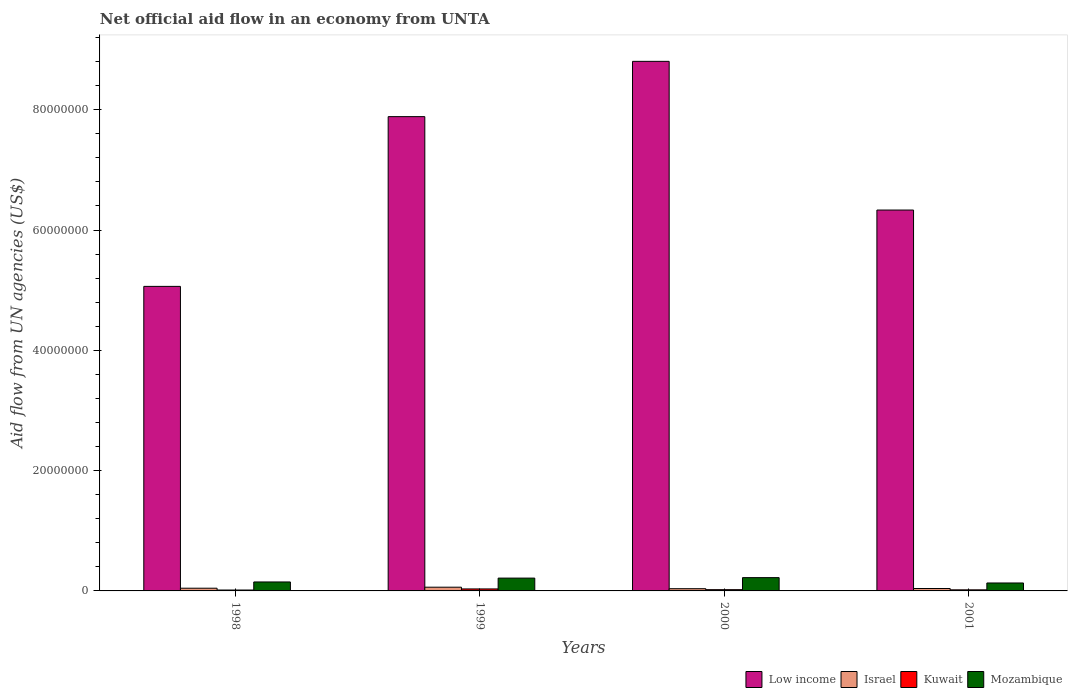How many different coloured bars are there?
Your response must be concise. 4. Are the number of bars per tick equal to the number of legend labels?
Keep it short and to the point. Yes. What is the label of the 4th group of bars from the left?
Keep it short and to the point. 2001. Across all years, what is the maximum net official aid flow in Mozambique?
Give a very brief answer. 2.21e+06. In which year was the net official aid flow in Israel minimum?
Ensure brevity in your answer.  2000. What is the total net official aid flow in Low income in the graph?
Provide a succinct answer. 2.81e+08. What is the difference between the net official aid flow in Israel in 2000 and that in 2001?
Your response must be concise. -3.00e+04. What is the difference between the net official aid flow in Kuwait in 2001 and the net official aid flow in Low income in 1999?
Give a very brief answer. -7.87e+07. What is the average net official aid flow in Mozambique per year?
Your response must be concise. 1.79e+06. In the year 1998, what is the difference between the net official aid flow in Mozambique and net official aid flow in Kuwait?
Offer a very short reply. 1.34e+06. What is the ratio of the net official aid flow in Mozambique in 1999 to that in 2000?
Keep it short and to the point. 0.96. Is the difference between the net official aid flow in Mozambique in 1999 and 2000 greater than the difference between the net official aid flow in Kuwait in 1999 and 2000?
Your answer should be compact. No. What is the difference between the highest and the lowest net official aid flow in Israel?
Your answer should be very brief. 2.50e+05. What does the 1st bar from the left in 2001 represents?
Give a very brief answer. Low income. What does the 1st bar from the right in 2001 represents?
Give a very brief answer. Mozambique. Are all the bars in the graph horizontal?
Offer a very short reply. No. What is the difference between two consecutive major ticks on the Y-axis?
Keep it short and to the point. 2.00e+07. Where does the legend appear in the graph?
Make the answer very short. Bottom right. How are the legend labels stacked?
Your answer should be compact. Horizontal. What is the title of the graph?
Your answer should be compact. Net official aid flow in an economy from UNTA. Does "Maldives" appear as one of the legend labels in the graph?
Keep it short and to the point. No. What is the label or title of the X-axis?
Give a very brief answer. Years. What is the label or title of the Y-axis?
Ensure brevity in your answer.  Aid flow from UN agencies (US$). What is the Aid flow from UN agencies (US$) of Low income in 1998?
Provide a short and direct response. 5.06e+07. What is the Aid flow from UN agencies (US$) in Kuwait in 1998?
Your response must be concise. 1.50e+05. What is the Aid flow from UN agencies (US$) of Mozambique in 1998?
Offer a very short reply. 1.49e+06. What is the Aid flow from UN agencies (US$) of Low income in 1999?
Keep it short and to the point. 7.88e+07. What is the Aid flow from UN agencies (US$) of Israel in 1999?
Make the answer very short. 6.20e+05. What is the Aid flow from UN agencies (US$) of Mozambique in 1999?
Keep it short and to the point. 2.13e+06. What is the Aid flow from UN agencies (US$) of Low income in 2000?
Ensure brevity in your answer.  8.80e+07. What is the Aid flow from UN agencies (US$) of Israel in 2000?
Provide a succinct answer. 3.70e+05. What is the Aid flow from UN agencies (US$) in Kuwait in 2000?
Give a very brief answer. 2.10e+05. What is the Aid flow from UN agencies (US$) in Mozambique in 2000?
Offer a terse response. 2.21e+06. What is the Aid flow from UN agencies (US$) of Low income in 2001?
Your answer should be compact. 6.33e+07. What is the Aid flow from UN agencies (US$) of Israel in 2001?
Provide a short and direct response. 4.00e+05. What is the Aid flow from UN agencies (US$) of Mozambique in 2001?
Offer a terse response. 1.32e+06. Across all years, what is the maximum Aid flow from UN agencies (US$) of Low income?
Give a very brief answer. 8.80e+07. Across all years, what is the maximum Aid flow from UN agencies (US$) in Israel?
Your response must be concise. 6.20e+05. Across all years, what is the maximum Aid flow from UN agencies (US$) of Mozambique?
Your response must be concise. 2.21e+06. Across all years, what is the minimum Aid flow from UN agencies (US$) of Low income?
Your response must be concise. 5.06e+07. Across all years, what is the minimum Aid flow from UN agencies (US$) in Israel?
Ensure brevity in your answer.  3.70e+05. Across all years, what is the minimum Aid flow from UN agencies (US$) of Kuwait?
Your answer should be compact. 1.50e+05. Across all years, what is the minimum Aid flow from UN agencies (US$) of Mozambique?
Your response must be concise. 1.32e+06. What is the total Aid flow from UN agencies (US$) of Low income in the graph?
Offer a terse response. 2.81e+08. What is the total Aid flow from UN agencies (US$) of Israel in the graph?
Offer a terse response. 1.84e+06. What is the total Aid flow from UN agencies (US$) in Kuwait in the graph?
Give a very brief answer. 8.70e+05. What is the total Aid flow from UN agencies (US$) of Mozambique in the graph?
Give a very brief answer. 7.15e+06. What is the difference between the Aid flow from UN agencies (US$) of Low income in 1998 and that in 1999?
Make the answer very short. -2.82e+07. What is the difference between the Aid flow from UN agencies (US$) in Israel in 1998 and that in 1999?
Provide a short and direct response. -1.70e+05. What is the difference between the Aid flow from UN agencies (US$) of Kuwait in 1998 and that in 1999?
Offer a very short reply. -1.80e+05. What is the difference between the Aid flow from UN agencies (US$) of Mozambique in 1998 and that in 1999?
Offer a terse response. -6.40e+05. What is the difference between the Aid flow from UN agencies (US$) of Low income in 1998 and that in 2000?
Your answer should be very brief. -3.74e+07. What is the difference between the Aid flow from UN agencies (US$) in Israel in 1998 and that in 2000?
Ensure brevity in your answer.  8.00e+04. What is the difference between the Aid flow from UN agencies (US$) of Mozambique in 1998 and that in 2000?
Your answer should be very brief. -7.20e+05. What is the difference between the Aid flow from UN agencies (US$) of Low income in 1998 and that in 2001?
Your answer should be very brief. -1.27e+07. What is the difference between the Aid flow from UN agencies (US$) in Low income in 1999 and that in 2000?
Provide a succinct answer. -9.19e+06. What is the difference between the Aid flow from UN agencies (US$) in Mozambique in 1999 and that in 2000?
Your response must be concise. -8.00e+04. What is the difference between the Aid flow from UN agencies (US$) in Low income in 1999 and that in 2001?
Make the answer very short. 1.55e+07. What is the difference between the Aid flow from UN agencies (US$) in Kuwait in 1999 and that in 2001?
Provide a short and direct response. 1.50e+05. What is the difference between the Aid flow from UN agencies (US$) of Mozambique in 1999 and that in 2001?
Your answer should be compact. 8.10e+05. What is the difference between the Aid flow from UN agencies (US$) in Low income in 2000 and that in 2001?
Your response must be concise. 2.47e+07. What is the difference between the Aid flow from UN agencies (US$) in Israel in 2000 and that in 2001?
Provide a short and direct response. -3.00e+04. What is the difference between the Aid flow from UN agencies (US$) of Mozambique in 2000 and that in 2001?
Your answer should be compact. 8.90e+05. What is the difference between the Aid flow from UN agencies (US$) of Low income in 1998 and the Aid flow from UN agencies (US$) of Israel in 1999?
Your response must be concise. 5.00e+07. What is the difference between the Aid flow from UN agencies (US$) in Low income in 1998 and the Aid flow from UN agencies (US$) in Kuwait in 1999?
Ensure brevity in your answer.  5.03e+07. What is the difference between the Aid flow from UN agencies (US$) in Low income in 1998 and the Aid flow from UN agencies (US$) in Mozambique in 1999?
Your response must be concise. 4.85e+07. What is the difference between the Aid flow from UN agencies (US$) in Israel in 1998 and the Aid flow from UN agencies (US$) in Kuwait in 1999?
Provide a short and direct response. 1.20e+05. What is the difference between the Aid flow from UN agencies (US$) of Israel in 1998 and the Aid flow from UN agencies (US$) of Mozambique in 1999?
Your answer should be compact. -1.68e+06. What is the difference between the Aid flow from UN agencies (US$) of Kuwait in 1998 and the Aid flow from UN agencies (US$) of Mozambique in 1999?
Give a very brief answer. -1.98e+06. What is the difference between the Aid flow from UN agencies (US$) in Low income in 1998 and the Aid flow from UN agencies (US$) in Israel in 2000?
Ensure brevity in your answer.  5.03e+07. What is the difference between the Aid flow from UN agencies (US$) of Low income in 1998 and the Aid flow from UN agencies (US$) of Kuwait in 2000?
Your answer should be very brief. 5.04e+07. What is the difference between the Aid flow from UN agencies (US$) in Low income in 1998 and the Aid flow from UN agencies (US$) in Mozambique in 2000?
Your answer should be compact. 4.84e+07. What is the difference between the Aid flow from UN agencies (US$) of Israel in 1998 and the Aid flow from UN agencies (US$) of Mozambique in 2000?
Your answer should be very brief. -1.76e+06. What is the difference between the Aid flow from UN agencies (US$) in Kuwait in 1998 and the Aid flow from UN agencies (US$) in Mozambique in 2000?
Offer a terse response. -2.06e+06. What is the difference between the Aid flow from UN agencies (US$) of Low income in 1998 and the Aid flow from UN agencies (US$) of Israel in 2001?
Offer a terse response. 5.02e+07. What is the difference between the Aid flow from UN agencies (US$) of Low income in 1998 and the Aid flow from UN agencies (US$) of Kuwait in 2001?
Keep it short and to the point. 5.04e+07. What is the difference between the Aid flow from UN agencies (US$) of Low income in 1998 and the Aid flow from UN agencies (US$) of Mozambique in 2001?
Provide a short and direct response. 4.93e+07. What is the difference between the Aid flow from UN agencies (US$) in Israel in 1998 and the Aid flow from UN agencies (US$) in Kuwait in 2001?
Provide a short and direct response. 2.70e+05. What is the difference between the Aid flow from UN agencies (US$) in Israel in 1998 and the Aid flow from UN agencies (US$) in Mozambique in 2001?
Provide a succinct answer. -8.70e+05. What is the difference between the Aid flow from UN agencies (US$) of Kuwait in 1998 and the Aid flow from UN agencies (US$) of Mozambique in 2001?
Provide a short and direct response. -1.17e+06. What is the difference between the Aid flow from UN agencies (US$) in Low income in 1999 and the Aid flow from UN agencies (US$) in Israel in 2000?
Offer a terse response. 7.85e+07. What is the difference between the Aid flow from UN agencies (US$) in Low income in 1999 and the Aid flow from UN agencies (US$) in Kuwait in 2000?
Offer a terse response. 7.86e+07. What is the difference between the Aid flow from UN agencies (US$) in Low income in 1999 and the Aid flow from UN agencies (US$) in Mozambique in 2000?
Your response must be concise. 7.66e+07. What is the difference between the Aid flow from UN agencies (US$) in Israel in 1999 and the Aid flow from UN agencies (US$) in Kuwait in 2000?
Provide a short and direct response. 4.10e+05. What is the difference between the Aid flow from UN agencies (US$) in Israel in 1999 and the Aid flow from UN agencies (US$) in Mozambique in 2000?
Provide a succinct answer. -1.59e+06. What is the difference between the Aid flow from UN agencies (US$) in Kuwait in 1999 and the Aid flow from UN agencies (US$) in Mozambique in 2000?
Offer a terse response. -1.88e+06. What is the difference between the Aid flow from UN agencies (US$) of Low income in 1999 and the Aid flow from UN agencies (US$) of Israel in 2001?
Ensure brevity in your answer.  7.84e+07. What is the difference between the Aid flow from UN agencies (US$) of Low income in 1999 and the Aid flow from UN agencies (US$) of Kuwait in 2001?
Your answer should be compact. 7.87e+07. What is the difference between the Aid flow from UN agencies (US$) of Low income in 1999 and the Aid flow from UN agencies (US$) of Mozambique in 2001?
Give a very brief answer. 7.75e+07. What is the difference between the Aid flow from UN agencies (US$) in Israel in 1999 and the Aid flow from UN agencies (US$) in Mozambique in 2001?
Your answer should be very brief. -7.00e+05. What is the difference between the Aid flow from UN agencies (US$) in Kuwait in 1999 and the Aid flow from UN agencies (US$) in Mozambique in 2001?
Keep it short and to the point. -9.90e+05. What is the difference between the Aid flow from UN agencies (US$) in Low income in 2000 and the Aid flow from UN agencies (US$) in Israel in 2001?
Give a very brief answer. 8.76e+07. What is the difference between the Aid flow from UN agencies (US$) of Low income in 2000 and the Aid flow from UN agencies (US$) of Kuwait in 2001?
Offer a very short reply. 8.79e+07. What is the difference between the Aid flow from UN agencies (US$) in Low income in 2000 and the Aid flow from UN agencies (US$) in Mozambique in 2001?
Your answer should be compact. 8.67e+07. What is the difference between the Aid flow from UN agencies (US$) in Israel in 2000 and the Aid flow from UN agencies (US$) in Mozambique in 2001?
Make the answer very short. -9.50e+05. What is the difference between the Aid flow from UN agencies (US$) in Kuwait in 2000 and the Aid flow from UN agencies (US$) in Mozambique in 2001?
Ensure brevity in your answer.  -1.11e+06. What is the average Aid flow from UN agencies (US$) in Low income per year?
Ensure brevity in your answer.  7.02e+07. What is the average Aid flow from UN agencies (US$) in Israel per year?
Make the answer very short. 4.60e+05. What is the average Aid flow from UN agencies (US$) of Kuwait per year?
Give a very brief answer. 2.18e+05. What is the average Aid flow from UN agencies (US$) of Mozambique per year?
Ensure brevity in your answer.  1.79e+06. In the year 1998, what is the difference between the Aid flow from UN agencies (US$) of Low income and Aid flow from UN agencies (US$) of Israel?
Ensure brevity in your answer.  5.02e+07. In the year 1998, what is the difference between the Aid flow from UN agencies (US$) in Low income and Aid flow from UN agencies (US$) in Kuwait?
Your response must be concise. 5.05e+07. In the year 1998, what is the difference between the Aid flow from UN agencies (US$) in Low income and Aid flow from UN agencies (US$) in Mozambique?
Make the answer very short. 4.91e+07. In the year 1998, what is the difference between the Aid flow from UN agencies (US$) of Israel and Aid flow from UN agencies (US$) of Mozambique?
Offer a terse response. -1.04e+06. In the year 1998, what is the difference between the Aid flow from UN agencies (US$) of Kuwait and Aid flow from UN agencies (US$) of Mozambique?
Your answer should be compact. -1.34e+06. In the year 1999, what is the difference between the Aid flow from UN agencies (US$) of Low income and Aid flow from UN agencies (US$) of Israel?
Your answer should be compact. 7.82e+07. In the year 1999, what is the difference between the Aid flow from UN agencies (US$) of Low income and Aid flow from UN agencies (US$) of Kuwait?
Offer a very short reply. 7.85e+07. In the year 1999, what is the difference between the Aid flow from UN agencies (US$) of Low income and Aid flow from UN agencies (US$) of Mozambique?
Your answer should be compact. 7.67e+07. In the year 1999, what is the difference between the Aid flow from UN agencies (US$) in Israel and Aid flow from UN agencies (US$) in Mozambique?
Keep it short and to the point. -1.51e+06. In the year 1999, what is the difference between the Aid flow from UN agencies (US$) in Kuwait and Aid flow from UN agencies (US$) in Mozambique?
Offer a very short reply. -1.80e+06. In the year 2000, what is the difference between the Aid flow from UN agencies (US$) of Low income and Aid flow from UN agencies (US$) of Israel?
Your response must be concise. 8.77e+07. In the year 2000, what is the difference between the Aid flow from UN agencies (US$) in Low income and Aid flow from UN agencies (US$) in Kuwait?
Provide a succinct answer. 8.78e+07. In the year 2000, what is the difference between the Aid flow from UN agencies (US$) in Low income and Aid flow from UN agencies (US$) in Mozambique?
Your answer should be very brief. 8.58e+07. In the year 2000, what is the difference between the Aid flow from UN agencies (US$) in Israel and Aid flow from UN agencies (US$) in Kuwait?
Your answer should be very brief. 1.60e+05. In the year 2000, what is the difference between the Aid flow from UN agencies (US$) in Israel and Aid flow from UN agencies (US$) in Mozambique?
Ensure brevity in your answer.  -1.84e+06. In the year 2001, what is the difference between the Aid flow from UN agencies (US$) of Low income and Aid flow from UN agencies (US$) of Israel?
Your answer should be very brief. 6.29e+07. In the year 2001, what is the difference between the Aid flow from UN agencies (US$) in Low income and Aid flow from UN agencies (US$) in Kuwait?
Make the answer very short. 6.31e+07. In the year 2001, what is the difference between the Aid flow from UN agencies (US$) in Low income and Aid flow from UN agencies (US$) in Mozambique?
Your response must be concise. 6.20e+07. In the year 2001, what is the difference between the Aid flow from UN agencies (US$) of Israel and Aid flow from UN agencies (US$) of Mozambique?
Offer a terse response. -9.20e+05. In the year 2001, what is the difference between the Aid flow from UN agencies (US$) of Kuwait and Aid flow from UN agencies (US$) of Mozambique?
Offer a terse response. -1.14e+06. What is the ratio of the Aid flow from UN agencies (US$) of Low income in 1998 to that in 1999?
Keep it short and to the point. 0.64. What is the ratio of the Aid flow from UN agencies (US$) of Israel in 1998 to that in 1999?
Your response must be concise. 0.73. What is the ratio of the Aid flow from UN agencies (US$) in Kuwait in 1998 to that in 1999?
Offer a terse response. 0.45. What is the ratio of the Aid flow from UN agencies (US$) of Mozambique in 1998 to that in 1999?
Your answer should be very brief. 0.7. What is the ratio of the Aid flow from UN agencies (US$) of Low income in 1998 to that in 2000?
Keep it short and to the point. 0.58. What is the ratio of the Aid flow from UN agencies (US$) of Israel in 1998 to that in 2000?
Give a very brief answer. 1.22. What is the ratio of the Aid flow from UN agencies (US$) in Mozambique in 1998 to that in 2000?
Keep it short and to the point. 0.67. What is the ratio of the Aid flow from UN agencies (US$) in Low income in 1998 to that in 2001?
Your response must be concise. 0.8. What is the ratio of the Aid flow from UN agencies (US$) in Israel in 1998 to that in 2001?
Offer a very short reply. 1.12. What is the ratio of the Aid flow from UN agencies (US$) in Mozambique in 1998 to that in 2001?
Your answer should be very brief. 1.13. What is the ratio of the Aid flow from UN agencies (US$) in Low income in 1999 to that in 2000?
Your response must be concise. 0.9. What is the ratio of the Aid flow from UN agencies (US$) of Israel in 1999 to that in 2000?
Keep it short and to the point. 1.68. What is the ratio of the Aid flow from UN agencies (US$) of Kuwait in 1999 to that in 2000?
Give a very brief answer. 1.57. What is the ratio of the Aid flow from UN agencies (US$) of Mozambique in 1999 to that in 2000?
Provide a succinct answer. 0.96. What is the ratio of the Aid flow from UN agencies (US$) in Low income in 1999 to that in 2001?
Your answer should be very brief. 1.25. What is the ratio of the Aid flow from UN agencies (US$) in Israel in 1999 to that in 2001?
Give a very brief answer. 1.55. What is the ratio of the Aid flow from UN agencies (US$) of Kuwait in 1999 to that in 2001?
Your response must be concise. 1.83. What is the ratio of the Aid flow from UN agencies (US$) in Mozambique in 1999 to that in 2001?
Provide a succinct answer. 1.61. What is the ratio of the Aid flow from UN agencies (US$) in Low income in 2000 to that in 2001?
Keep it short and to the point. 1.39. What is the ratio of the Aid flow from UN agencies (US$) of Israel in 2000 to that in 2001?
Give a very brief answer. 0.93. What is the ratio of the Aid flow from UN agencies (US$) of Mozambique in 2000 to that in 2001?
Offer a terse response. 1.67. What is the difference between the highest and the second highest Aid flow from UN agencies (US$) of Low income?
Your response must be concise. 9.19e+06. What is the difference between the highest and the second highest Aid flow from UN agencies (US$) in Kuwait?
Your answer should be very brief. 1.20e+05. What is the difference between the highest and the lowest Aid flow from UN agencies (US$) of Low income?
Ensure brevity in your answer.  3.74e+07. What is the difference between the highest and the lowest Aid flow from UN agencies (US$) of Kuwait?
Make the answer very short. 1.80e+05. What is the difference between the highest and the lowest Aid flow from UN agencies (US$) in Mozambique?
Provide a short and direct response. 8.90e+05. 